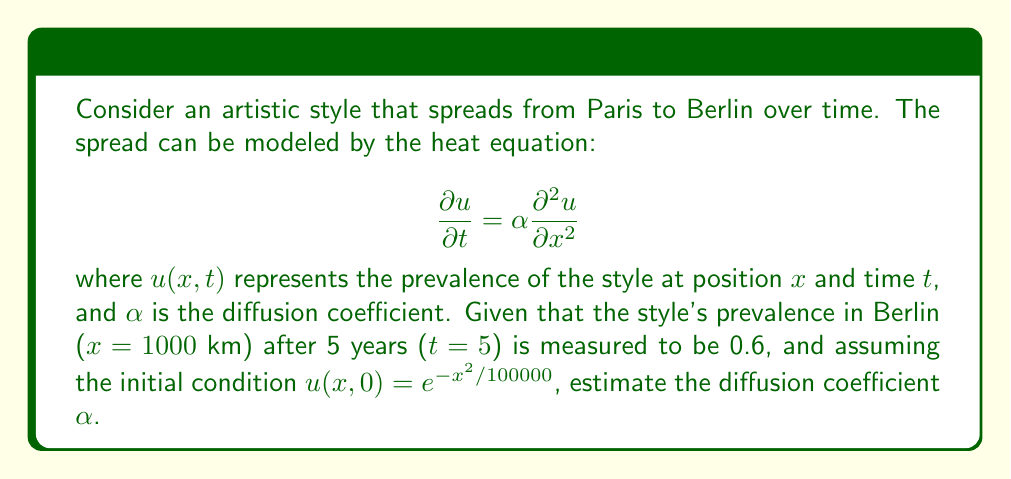Can you answer this question? To solve this inverse problem, we'll follow these steps:

1) The solution to the heat equation with the given initial condition is:

   $$u(x,t) = \frac{1}{\sqrt{1+4\alpha t/100000}} \exp\left(-\frac{x^2}{100000(1+4\alpha t/100000)}\right)$$

2) We're given that $u(1000,5) = 0.6$. Let's substitute these values:

   $$0.6 = \frac{1}{\sqrt{1+4\alpha \cdot 5/100000}} \exp\left(-\frac{1000^2}{100000(1+4\alpha \cdot 5/100000)}\right)$$

3) Let's simplify by setting $y = 1+4\alpha \cdot 5/100000 = 1+\alpha/5000$:

   $$0.6 = \frac{1}{\sqrt{y}} \exp\left(-\frac{10}{y}\right)$$

4) Taking the natural log of both sides:

   $$\ln(0.6) = -\frac{1}{2}\ln(y) - \frac{10}{y}$$

5) This is a nonlinear equation in $y$. We can solve it numerically using Newton's method or other numerical techniques. The solution is approximately $y \approx 1.3815$.

6) Now we can solve for $\alpha$:

   $$1.3815 = 1 + \frac{\alpha}{5000}$$
   $$\alpha = 5000 \cdot 0.3815 = 1907.5$$

Therefore, the estimated diffusion coefficient $\alpha$ is approximately 1907.5 km²/year.
Answer: $\alpha \approx 1907.5$ km²/year 